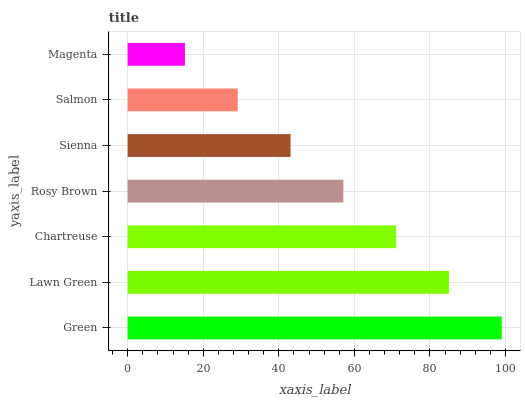Is Magenta the minimum?
Answer yes or no. Yes. Is Green the maximum?
Answer yes or no. Yes. Is Lawn Green the minimum?
Answer yes or no. No. Is Lawn Green the maximum?
Answer yes or no. No. Is Green greater than Lawn Green?
Answer yes or no. Yes. Is Lawn Green less than Green?
Answer yes or no. Yes. Is Lawn Green greater than Green?
Answer yes or no. No. Is Green less than Lawn Green?
Answer yes or no. No. Is Rosy Brown the high median?
Answer yes or no. Yes. Is Rosy Brown the low median?
Answer yes or no. Yes. Is Salmon the high median?
Answer yes or no. No. Is Magenta the low median?
Answer yes or no. No. 